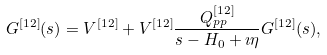<formula> <loc_0><loc_0><loc_500><loc_500>G ^ { [ 1 2 ] } ( s ) = V ^ { [ 1 2 ] } + V ^ { [ 1 2 ] } \frac { Q ^ { [ 1 2 ] } _ { p p } } { s - H _ { 0 } + \imath \eta } G ^ { [ 1 2 ] } ( s ) ,</formula> 